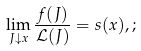<formula> <loc_0><loc_0><loc_500><loc_500>\lim _ { J \downarrow x } \frac { f ( J ) } { \mathcal { L } ( J ) } = s ( x ) , ;</formula> 